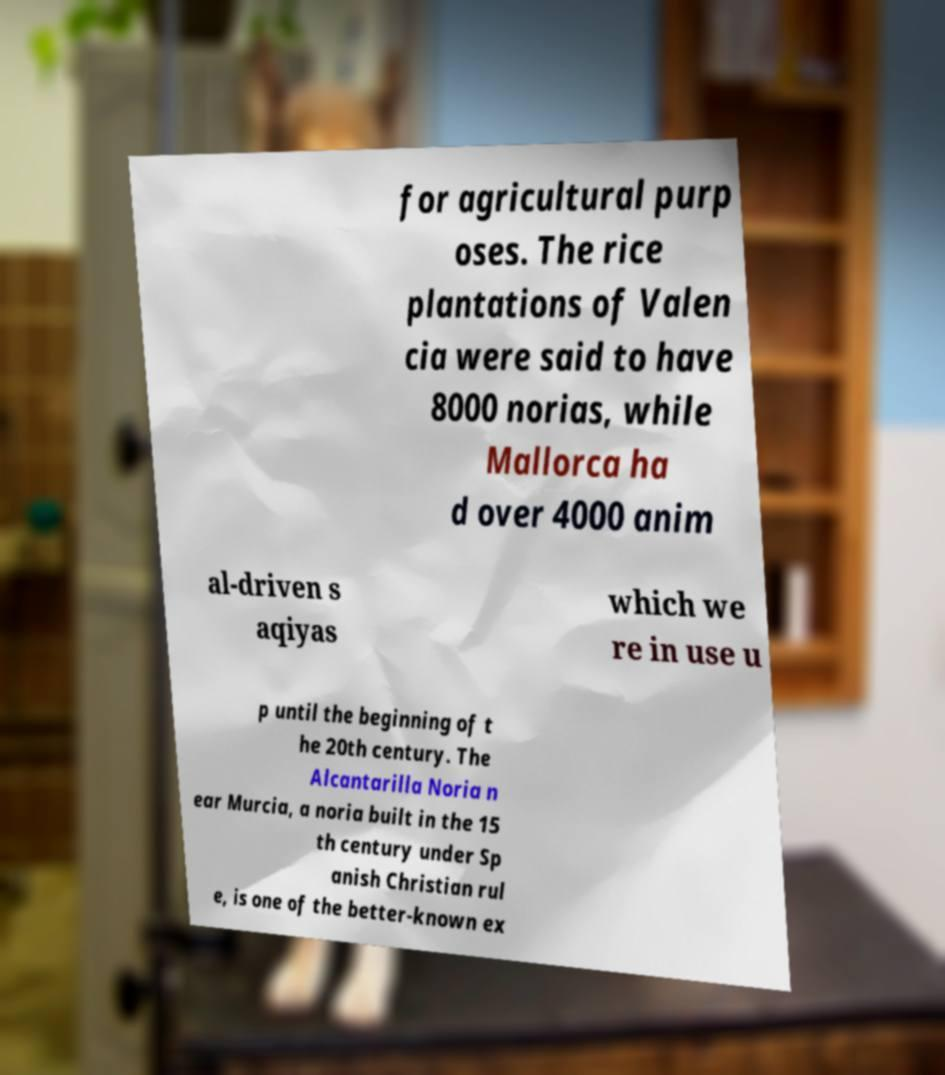Could you assist in decoding the text presented in this image and type it out clearly? for agricultural purp oses. The rice plantations of Valen cia were said to have 8000 norias, while Mallorca ha d over 4000 anim al-driven s aqiyas which we re in use u p until the beginning of t he 20th century. The Alcantarilla Noria n ear Murcia, a noria built in the 15 th century under Sp anish Christian rul e, is one of the better-known ex 